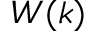Convert formula to latex. <formula><loc_0><loc_0><loc_500><loc_500>W ( k )</formula> 